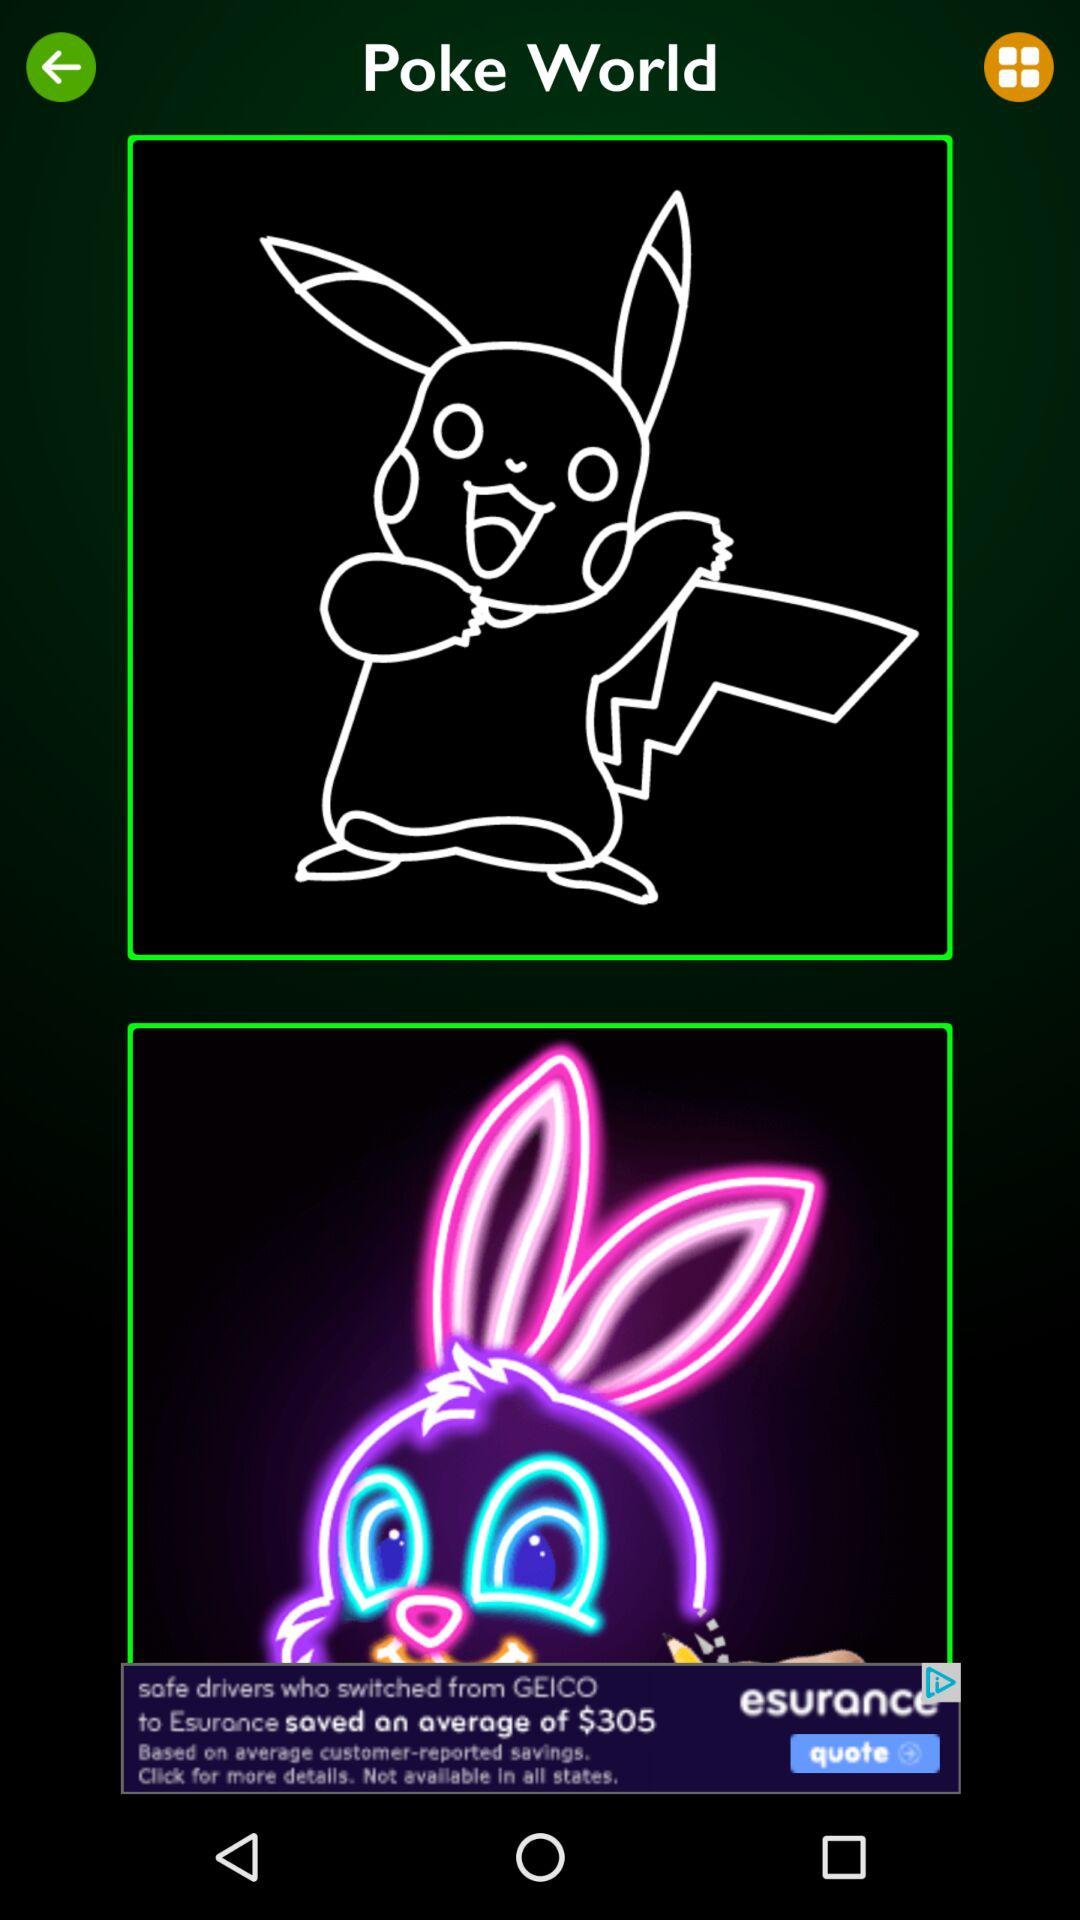What is the application name? The application name is "Poke World". 